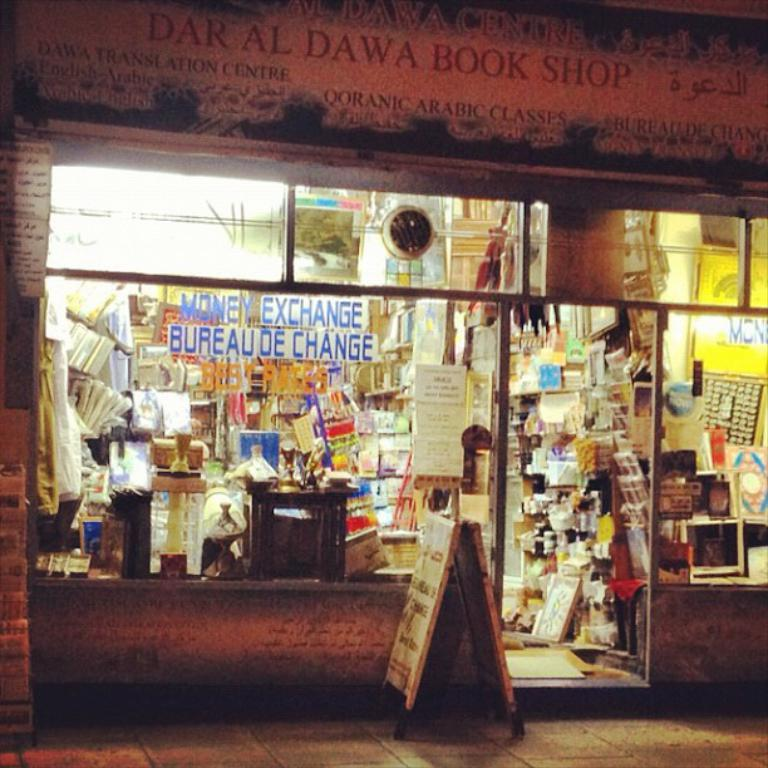<image>
Present a compact description of the photo's key features. The display window of  the dar al dawa book shop. 